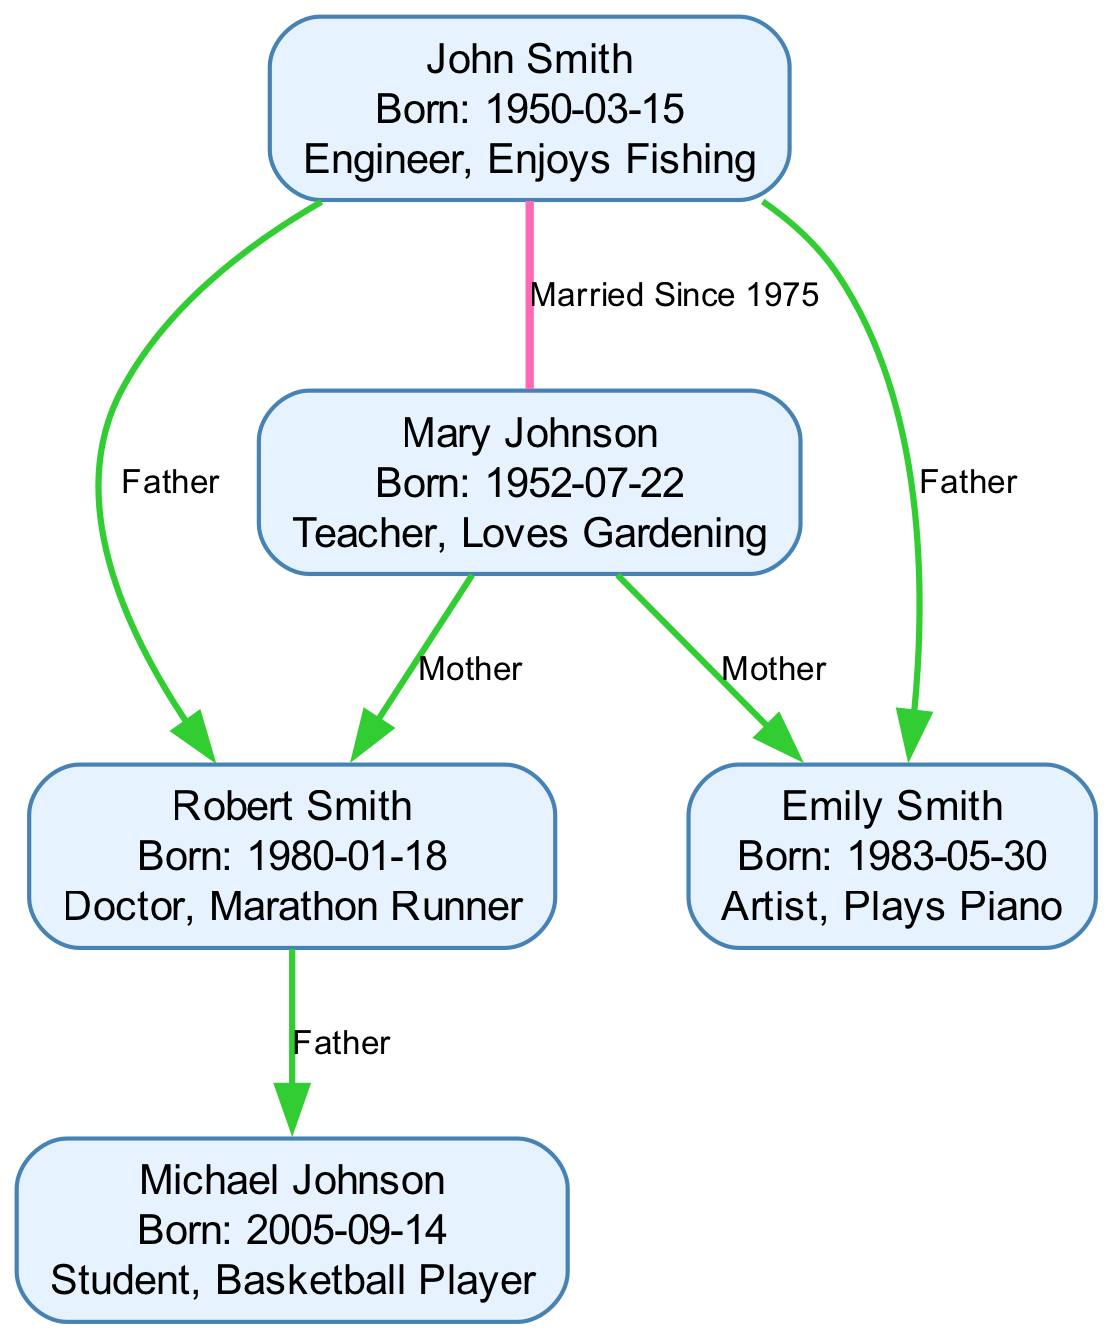What is the birthdate of John Smith? The diagram shows that John Smith's birthdate is directly listed next to his name in the node information. By locating the specific node for John Smith, we can see his birthdate is 1950-03-15.
Answer: 1950-03-15 How many individuals are in the family tree? The diagram consists of five distinct nodes representing individuals. By counting each node presented—John Smith, Mary Johnson, Robert Smith, Emily Smith, and Michael Johnson—we determine the total number is five.
Answer: 5 What type of relationship do John Smith and Mary Johnson have? In the diagram, there's an edge connecting John Smith and Mary Johnson. The edge is labeled "Married Since 1975," indicating their relationship is that of marriage.
Answer: Marriage Who are the parents of Robert Smith? The diagram connects Robert Smith to two nodes: John Smith and Mary Johnson through "parent-child" edges. John Smith is labeled as the father and Mary Johnson as the mother, showing they are both his parents.
Answer: John Smith and Mary Johnson What year was Michael Johnson born? The birthdate of Michael Johnson is noted directly inside the node allocated for him. After reviewing his node, we find the birthdate is specified as 2005-09-14.
Answer: 2005-09-14 Which individual is described as an artist? The node for Emily Smith includes a description stating she is an artist and plays the piano. By analyzing each node individually, we can determine that Emily Smith is the artist.
Answer: Emily Smith How many edges indicate parent-child relationships? The diagram contains a total of four edges that connect parents to children, specified by the "parent-child" relationship type. By examining each edge type, we find these four distinct connections indicate parent-child relationships.
Answer: 4 What is the occupation of Mary Johnson? Within the node for Mary Johnson, it explicitly states her profession is a teacher, accompanied by her interest in gardening. This information is directly visible in her node description.
Answer: Teacher Which node has the detail "Enjoys Fishing"? The detail "Enjoys Fishing" is specifically associated with John Smith’s node. This piece of information is displayed alongside his birthdate and occupation in the diagram.
Answer: John Smith 